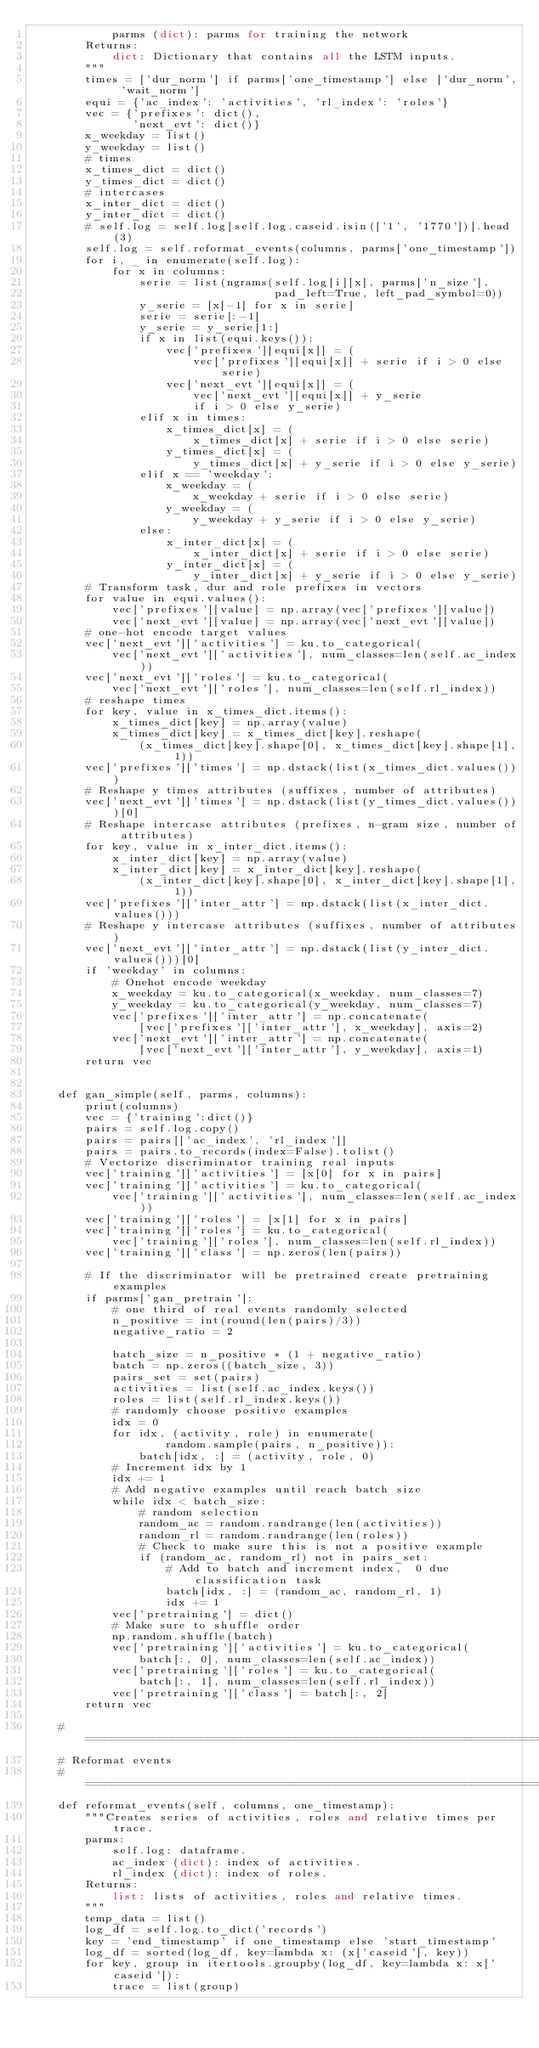<code> <loc_0><loc_0><loc_500><loc_500><_Python_>            parms (dict): parms for training the network
        Returns:
            dict: Dictionary that contains all the LSTM inputs.
        """
        times = ['dur_norm'] if parms['one_timestamp'] else ['dur_norm', 'wait_norm']
        equi = {'ac_index': 'activities', 'rl_index': 'roles'}
        vec = {'prefixes': dict(),
               'next_evt': dict()}
        x_weekday = list()
        y_weekday = list()
        # times
        x_times_dict = dict()
        y_times_dict = dict()
        # intercases
        x_inter_dict = dict()
        y_inter_dict = dict()
        # self.log = self.log[self.log.caseid.isin(['1', '1770'])].head(3)
        self.log = self.reformat_events(columns, parms['one_timestamp'])
        for i, _ in enumerate(self.log):
            for x in columns:
                serie = list(ngrams(self.log[i][x], parms['n_size'],
                                    pad_left=True, left_pad_symbol=0))
                y_serie = [x[-1] for x in serie]
                serie = serie[:-1]
                y_serie = y_serie[1:]
                if x in list(equi.keys()):
                    vec['prefixes'][equi[x]] = (
                        vec['prefixes'][equi[x]] + serie if i > 0 else serie)
                    vec['next_evt'][equi[x]] = (
                        vec['next_evt'][equi[x]] + y_serie
                        if i > 0 else y_serie)
                elif x in times:
                    x_times_dict[x] = (
                        x_times_dict[x] + serie if i > 0 else serie)
                    y_times_dict[x] = (
                        y_times_dict[x] + y_serie if i > 0 else y_serie)
                elif x == 'weekday':
                    x_weekday = (
                        x_weekday + serie if i > 0 else serie)
                    y_weekday = (
                        y_weekday + y_serie if i > 0 else y_serie)
                else:
                    x_inter_dict[x] = (
                        x_inter_dict[x] + serie if i > 0 else serie)
                    y_inter_dict[x] = (
                        y_inter_dict[x] + y_serie if i > 0 else y_serie)
        # Transform task, dur and role prefixes in vectors
        for value in equi.values():
            vec['prefixes'][value] = np.array(vec['prefixes'][value])
            vec['next_evt'][value] = np.array(vec['next_evt'][value])
        # one-hot encode target values
        vec['next_evt']['activities'] = ku.to_categorical(
            vec['next_evt']['activities'], num_classes=len(self.ac_index))
        vec['next_evt']['roles'] = ku.to_categorical(
            vec['next_evt']['roles'], num_classes=len(self.rl_index))
        # reshape times
        for key, value in x_times_dict.items():
            x_times_dict[key] = np.array(value)
            x_times_dict[key] = x_times_dict[key].reshape(
                (x_times_dict[key].shape[0], x_times_dict[key].shape[1], 1))
        vec['prefixes']['times'] = np.dstack(list(x_times_dict.values()))
        # Reshape y times attributes (suffixes, number of attributes)
        vec['next_evt']['times'] = np.dstack(list(y_times_dict.values()))[0]
        # Reshape intercase attributes (prefixes, n-gram size, number of attributes)
        for key, value in x_inter_dict.items():
            x_inter_dict[key] = np.array(value)
            x_inter_dict[key] = x_inter_dict[key].reshape(
                (x_inter_dict[key].shape[0], x_inter_dict[key].shape[1], 1))
        vec['prefixes']['inter_attr'] = np.dstack(list(x_inter_dict.values()))
        # Reshape y intercase attributes (suffixes, number of attributes)
        vec['next_evt']['inter_attr'] = np.dstack(list(y_inter_dict.values()))[0]
        if 'weekday' in columns:
            # Onehot encode weekday
            x_weekday = ku.to_categorical(x_weekday, num_classes=7)
            y_weekday = ku.to_categorical(y_weekday, num_classes=7)
            vec['prefixes']['inter_attr'] = np.concatenate(
                [vec['prefixes']['inter_attr'], x_weekday], axis=2)
            vec['next_evt']['inter_attr'] = np.concatenate(
                [vec['next_evt']['inter_attr'], y_weekday], axis=1)
        return vec


    def gan_simple(self, parms, columns):
        print(columns)
        vec = {'training':dict()}
        pairs = self.log.copy()
        pairs = pairs[['ac_index', 'rl_index']]
        pairs = pairs.to_records(index=False).tolist()
        # Vectorize discriminator training real inputs
        vec['training']['activities'] = [x[0] for x in pairs]
        vec['training']['activities'] = ku.to_categorical(
            vec['training']['activities'], num_classes=len(self.ac_index))
        vec['training']['roles'] = [x[1] for x in pairs]
        vec['training']['roles'] = ku.to_categorical(
            vec['training']['roles'], num_classes=len(self.rl_index))
        vec['training']['class'] = np.zeros(len(pairs))
        
        # If the discriminator will be pretrained create pretraining examples
        if parms['gan_pretrain']:
            # one third of real events randomly selected
            n_positive = int(round(len(pairs)/3))
            negative_ratio = 2
    
            batch_size = n_positive * (1 + negative_ratio)
            batch = np.zeros((batch_size, 3))
            pairs_set = set(pairs)
            activities = list(self.ac_index.keys())
            roles = list(self.rl_index.keys())
            # randomly choose positive examples
            idx = 0
            for idx, (activity, role) in enumerate(
                    random.sample(pairs, n_positive)):
                batch[idx, :] = (activity, role, 0)
            # Increment idx by 1
            idx += 1
            # Add negative examples until reach batch size
            while idx < batch_size:
                # random selection
                random_ac = random.randrange(len(activities))
                random_rl = random.randrange(len(roles))
                # Check to make sure this is not a positive example
                if (random_ac, random_rl) not in pairs_set:
                    # Add to batch and increment index,  0 due classification task
                    batch[idx, :] = (random_ac, random_rl, 1)
                    idx += 1
            vec['pretraining'] = dict()
            # Make sure to shuffle order
            np.random.shuffle(batch)
            vec['pretraining']['activities'] = ku.to_categorical(
                batch[:, 0], num_classes=len(self.ac_index))
            vec['pretraining']['roles'] = ku.to_categorical(
                batch[:, 1], num_classes=len(self.rl_index))
            vec['pretraining']['class'] = batch[:, 2]
        return vec

    # =============================================================================
    # Reformat events
    # =============================================================================
    def reformat_events(self, columns, one_timestamp):
        """Creates series of activities, roles and relative times per trace.
        parms:
            self.log: dataframe.
            ac_index (dict): index of activities.
            rl_index (dict): index of roles.
        Returns:
            list: lists of activities, roles and relative times.
        """
        temp_data = list()
        log_df = self.log.to_dict('records')
        key = 'end_timestamp' if one_timestamp else 'start_timestamp'
        log_df = sorted(log_df, key=lambda x: (x['caseid'], key))
        for key, group in itertools.groupby(log_df, key=lambda x: x['caseid']):
            trace = list(group)</code> 